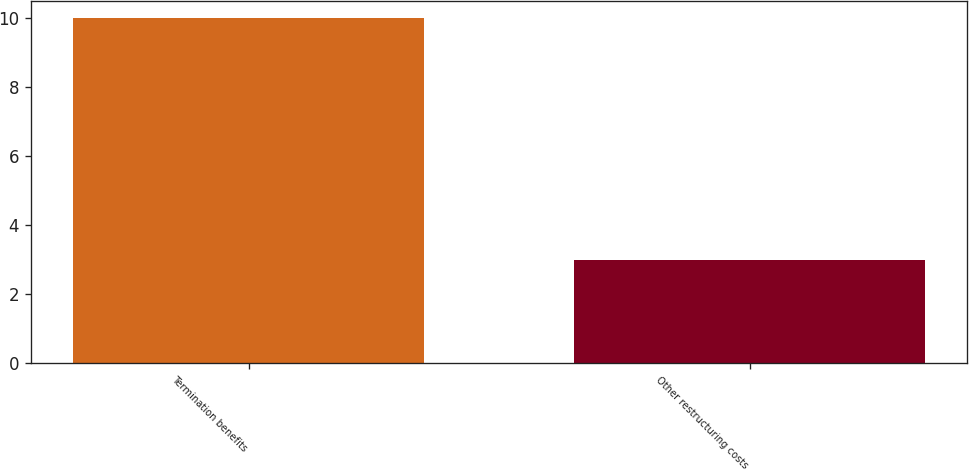Convert chart to OTSL. <chart><loc_0><loc_0><loc_500><loc_500><bar_chart><fcel>Termination benefits<fcel>Other restructuring costs<nl><fcel>10<fcel>3<nl></chart> 